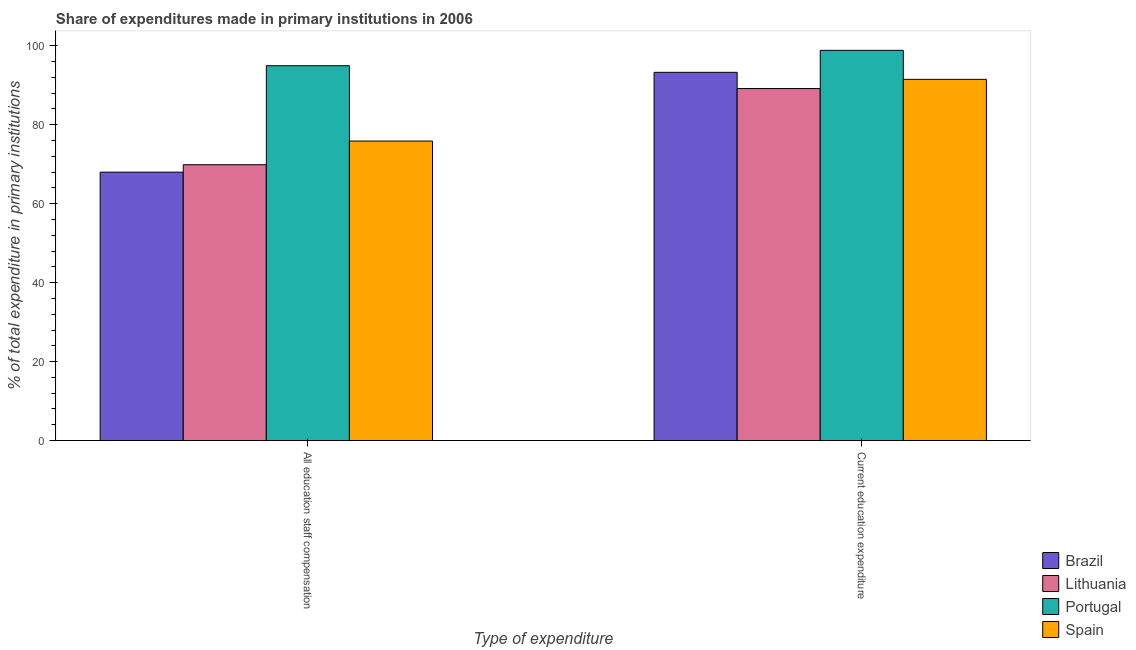Are the number of bars on each tick of the X-axis equal?
Your answer should be compact. Yes. What is the label of the 1st group of bars from the left?
Provide a short and direct response. All education staff compensation. What is the expenditure in staff compensation in Portugal?
Provide a succinct answer. 94.93. Across all countries, what is the maximum expenditure in education?
Keep it short and to the point. 98.83. Across all countries, what is the minimum expenditure in education?
Provide a short and direct response. 89.16. In which country was the expenditure in staff compensation maximum?
Offer a terse response. Portugal. In which country was the expenditure in education minimum?
Keep it short and to the point. Lithuania. What is the total expenditure in staff compensation in the graph?
Provide a succinct answer. 308.63. What is the difference between the expenditure in education in Portugal and that in Lithuania?
Keep it short and to the point. 9.68. What is the difference between the expenditure in staff compensation in Lithuania and the expenditure in education in Brazil?
Your answer should be compact. -23.4. What is the average expenditure in staff compensation per country?
Your answer should be very brief. 77.16. What is the difference between the expenditure in staff compensation and expenditure in education in Spain?
Keep it short and to the point. -15.63. What is the ratio of the expenditure in education in Spain to that in Lithuania?
Keep it short and to the point. 1.03. Is the expenditure in staff compensation in Lithuania less than that in Portugal?
Ensure brevity in your answer.  Yes. What does the 3rd bar from the right in Current education expenditure represents?
Give a very brief answer. Lithuania. Are all the bars in the graph horizontal?
Your answer should be very brief. No. How many countries are there in the graph?
Your answer should be compact. 4. Are the values on the major ticks of Y-axis written in scientific E-notation?
Your answer should be very brief. No. Does the graph contain grids?
Offer a very short reply. No. Where does the legend appear in the graph?
Offer a terse response. Bottom right. How many legend labels are there?
Your response must be concise. 4. How are the legend labels stacked?
Provide a short and direct response. Vertical. What is the title of the graph?
Ensure brevity in your answer.  Share of expenditures made in primary institutions in 2006. What is the label or title of the X-axis?
Make the answer very short. Type of expenditure. What is the label or title of the Y-axis?
Your answer should be very brief. % of total expenditure in primary institutions. What is the % of total expenditure in primary institutions in Brazil in All education staff compensation?
Offer a terse response. 67.98. What is the % of total expenditure in primary institutions of Lithuania in All education staff compensation?
Offer a terse response. 69.86. What is the % of total expenditure in primary institutions in Portugal in All education staff compensation?
Offer a terse response. 94.93. What is the % of total expenditure in primary institutions of Spain in All education staff compensation?
Make the answer very short. 75.86. What is the % of total expenditure in primary institutions of Brazil in Current education expenditure?
Provide a succinct answer. 93.27. What is the % of total expenditure in primary institutions in Lithuania in Current education expenditure?
Offer a very short reply. 89.16. What is the % of total expenditure in primary institutions of Portugal in Current education expenditure?
Give a very brief answer. 98.83. What is the % of total expenditure in primary institutions in Spain in Current education expenditure?
Offer a terse response. 91.49. Across all Type of expenditure, what is the maximum % of total expenditure in primary institutions of Brazil?
Provide a short and direct response. 93.27. Across all Type of expenditure, what is the maximum % of total expenditure in primary institutions of Lithuania?
Your answer should be compact. 89.16. Across all Type of expenditure, what is the maximum % of total expenditure in primary institutions of Portugal?
Keep it short and to the point. 98.83. Across all Type of expenditure, what is the maximum % of total expenditure in primary institutions in Spain?
Ensure brevity in your answer.  91.49. Across all Type of expenditure, what is the minimum % of total expenditure in primary institutions in Brazil?
Provide a succinct answer. 67.98. Across all Type of expenditure, what is the minimum % of total expenditure in primary institutions in Lithuania?
Offer a terse response. 69.86. Across all Type of expenditure, what is the minimum % of total expenditure in primary institutions of Portugal?
Provide a succinct answer. 94.93. Across all Type of expenditure, what is the minimum % of total expenditure in primary institutions of Spain?
Give a very brief answer. 75.86. What is the total % of total expenditure in primary institutions of Brazil in the graph?
Offer a terse response. 161.24. What is the total % of total expenditure in primary institutions of Lithuania in the graph?
Provide a succinct answer. 159.02. What is the total % of total expenditure in primary institutions in Portugal in the graph?
Provide a short and direct response. 193.77. What is the total % of total expenditure in primary institutions in Spain in the graph?
Your answer should be very brief. 167.35. What is the difference between the % of total expenditure in primary institutions in Brazil in All education staff compensation and that in Current education expenditure?
Make the answer very short. -25.29. What is the difference between the % of total expenditure in primary institutions in Lithuania in All education staff compensation and that in Current education expenditure?
Offer a very short reply. -19.29. What is the difference between the % of total expenditure in primary institutions in Portugal in All education staff compensation and that in Current education expenditure?
Your answer should be very brief. -3.9. What is the difference between the % of total expenditure in primary institutions in Spain in All education staff compensation and that in Current education expenditure?
Keep it short and to the point. -15.63. What is the difference between the % of total expenditure in primary institutions of Brazil in All education staff compensation and the % of total expenditure in primary institutions of Lithuania in Current education expenditure?
Your answer should be very brief. -21.18. What is the difference between the % of total expenditure in primary institutions in Brazil in All education staff compensation and the % of total expenditure in primary institutions in Portugal in Current education expenditure?
Make the answer very short. -30.85. What is the difference between the % of total expenditure in primary institutions of Brazil in All education staff compensation and the % of total expenditure in primary institutions of Spain in Current education expenditure?
Offer a very short reply. -23.51. What is the difference between the % of total expenditure in primary institutions in Lithuania in All education staff compensation and the % of total expenditure in primary institutions in Portugal in Current education expenditure?
Keep it short and to the point. -28.97. What is the difference between the % of total expenditure in primary institutions in Lithuania in All education staff compensation and the % of total expenditure in primary institutions in Spain in Current education expenditure?
Offer a very short reply. -21.62. What is the difference between the % of total expenditure in primary institutions in Portugal in All education staff compensation and the % of total expenditure in primary institutions in Spain in Current education expenditure?
Offer a very short reply. 3.45. What is the average % of total expenditure in primary institutions in Brazil per Type of expenditure?
Provide a succinct answer. 80.62. What is the average % of total expenditure in primary institutions of Lithuania per Type of expenditure?
Make the answer very short. 79.51. What is the average % of total expenditure in primary institutions of Portugal per Type of expenditure?
Ensure brevity in your answer.  96.88. What is the average % of total expenditure in primary institutions of Spain per Type of expenditure?
Your answer should be compact. 83.67. What is the difference between the % of total expenditure in primary institutions in Brazil and % of total expenditure in primary institutions in Lithuania in All education staff compensation?
Keep it short and to the point. -1.88. What is the difference between the % of total expenditure in primary institutions of Brazil and % of total expenditure in primary institutions of Portugal in All education staff compensation?
Give a very brief answer. -26.95. What is the difference between the % of total expenditure in primary institutions of Brazil and % of total expenditure in primary institutions of Spain in All education staff compensation?
Your answer should be compact. -7.88. What is the difference between the % of total expenditure in primary institutions of Lithuania and % of total expenditure in primary institutions of Portugal in All education staff compensation?
Your answer should be compact. -25.07. What is the difference between the % of total expenditure in primary institutions in Lithuania and % of total expenditure in primary institutions in Spain in All education staff compensation?
Your answer should be compact. -6. What is the difference between the % of total expenditure in primary institutions of Portugal and % of total expenditure in primary institutions of Spain in All education staff compensation?
Provide a short and direct response. 19.07. What is the difference between the % of total expenditure in primary institutions of Brazil and % of total expenditure in primary institutions of Lithuania in Current education expenditure?
Keep it short and to the point. 4.11. What is the difference between the % of total expenditure in primary institutions in Brazil and % of total expenditure in primary institutions in Portugal in Current education expenditure?
Offer a very short reply. -5.57. What is the difference between the % of total expenditure in primary institutions in Brazil and % of total expenditure in primary institutions in Spain in Current education expenditure?
Ensure brevity in your answer.  1.78. What is the difference between the % of total expenditure in primary institutions of Lithuania and % of total expenditure in primary institutions of Portugal in Current education expenditure?
Offer a very short reply. -9.68. What is the difference between the % of total expenditure in primary institutions of Lithuania and % of total expenditure in primary institutions of Spain in Current education expenditure?
Provide a short and direct response. -2.33. What is the difference between the % of total expenditure in primary institutions in Portugal and % of total expenditure in primary institutions in Spain in Current education expenditure?
Offer a very short reply. 7.35. What is the ratio of the % of total expenditure in primary institutions of Brazil in All education staff compensation to that in Current education expenditure?
Ensure brevity in your answer.  0.73. What is the ratio of the % of total expenditure in primary institutions in Lithuania in All education staff compensation to that in Current education expenditure?
Provide a succinct answer. 0.78. What is the ratio of the % of total expenditure in primary institutions of Portugal in All education staff compensation to that in Current education expenditure?
Provide a succinct answer. 0.96. What is the ratio of the % of total expenditure in primary institutions in Spain in All education staff compensation to that in Current education expenditure?
Provide a succinct answer. 0.83. What is the difference between the highest and the second highest % of total expenditure in primary institutions in Brazil?
Offer a very short reply. 25.29. What is the difference between the highest and the second highest % of total expenditure in primary institutions of Lithuania?
Keep it short and to the point. 19.29. What is the difference between the highest and the second highest % of total expenditure in primary institutions in Portugal?
Make the answer very short. 3.9. What is the difference between the highest and the second highest % of total expenditure in primary institutions in Spain?
Offer a very short reply. 15.63. What is the difference between the highest and the lowest % of total expenditure in primary institutions of Brazil?
Provide a short and direct response. 25.29. What is the difference between the highest and the lowest % of total expenditure in primary institutions of Lithuania?
Your response must be concise. 19.29. What is the difference between the highest and the lowest % of total expenditure in primary institutions of Portugal?
Ensure brevity in your answer.  3.9. What is the difference between the highest and the lowest % of total expenditure in primary institutions in Spain?
Your answer should be compact. 15.63. 